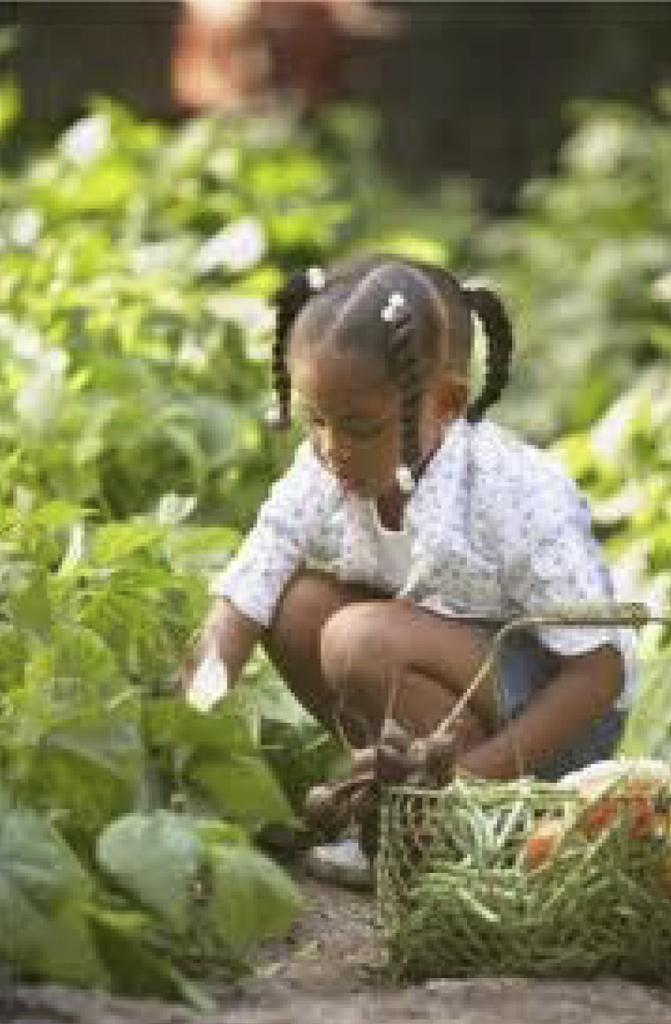Who is the main subject in the image? There is a girl sitting in the middle of the image. What object can be seen near the girl? There is a basket in the image. What type of setting is visible in the background of the image? There are plants in the background of the image. How would you describe the background's appearance? The background of the image is blurred. What type of bun is the girl holding in the image? There is no bun present in the image. How does the engine in the image help the girl? There is no engine present in the image, so it cannot help the girl. 